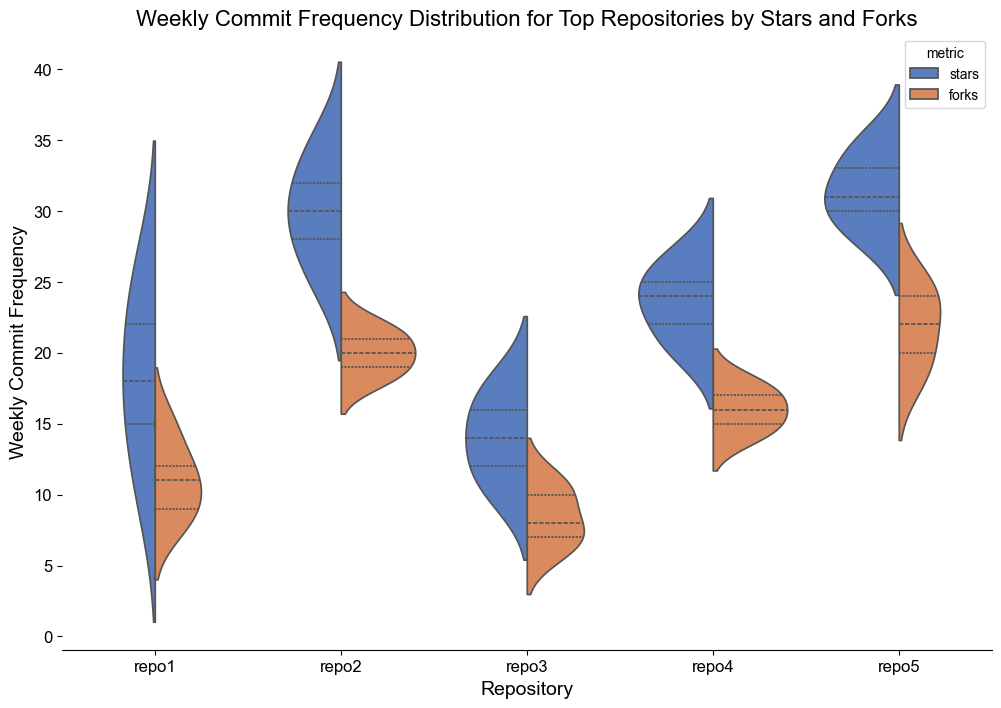What's the repository with the highest median commit frequency for stars? By visually inspecting the violin plots, we look at the median lines within the 'stars' distributions. The repository with the median line located highest along the y-axis among 'stars' is repo2.
Answer: repo2 Which repository has the least variation in commit frequency for forks? We check which violin plot under the 'forks' metric is the narrowest. The narrower the plot, the less variation in the commit frequencies. Repo3 has the narrowest violin plot under 'forks'.
Answer: repo3 How does the median commit frequency for forks in repo1 compare to that in repo5? We identify the median lines within the violin plots for 'forks' in repo1 and repo5. In repo1, the median fork commit frequency is lower than in repo5, as the median line is lower in y-axis position.
Answer: Repo1's median is lower What is the approximate range of commit frequency for stars in repo5? By observing the vertical extent of the violin plot for 'stars' in repo5, the range can be estimated from the bottom to the top point. The commit frequency ranges roughly from 28 to 35.
Answer: 28 to 35 Which repository shows a bimodal distribution for stars? We look for violin plots under the 'stars' metric which show two distinct peaks or bulges. Repo4 has a bimodal distribution for stars.
Answer: repo4 Which metric generally has a higher commit frequency in repo2? By comparing the max ranges and medians within repo2's 'stars' and 'forks' violin plots, the 'stars' metric consistently shows higher commit frequencies.
Answer: stars What's the difference between the highest and lowest commit frequency for forks in repo4? The range for forks in repo4 can be determined by identifying the highest and lowest y-axis points of the violin plot. The highest is 18 and the lowest is 14, resulting in a difference of 4.
Answer: 4 Does repo3 have a higher average commit frequency in stars or forks? By looking at the overall shape and central tendencies of the violin plots for repo3, the average commit frequency in 'stars' appears generally higher than in 'forks'.
Answer: stars 